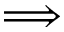<formula> <loc_0><loc_0><loc_500><loc_500>\Longrightarrow</formula> 